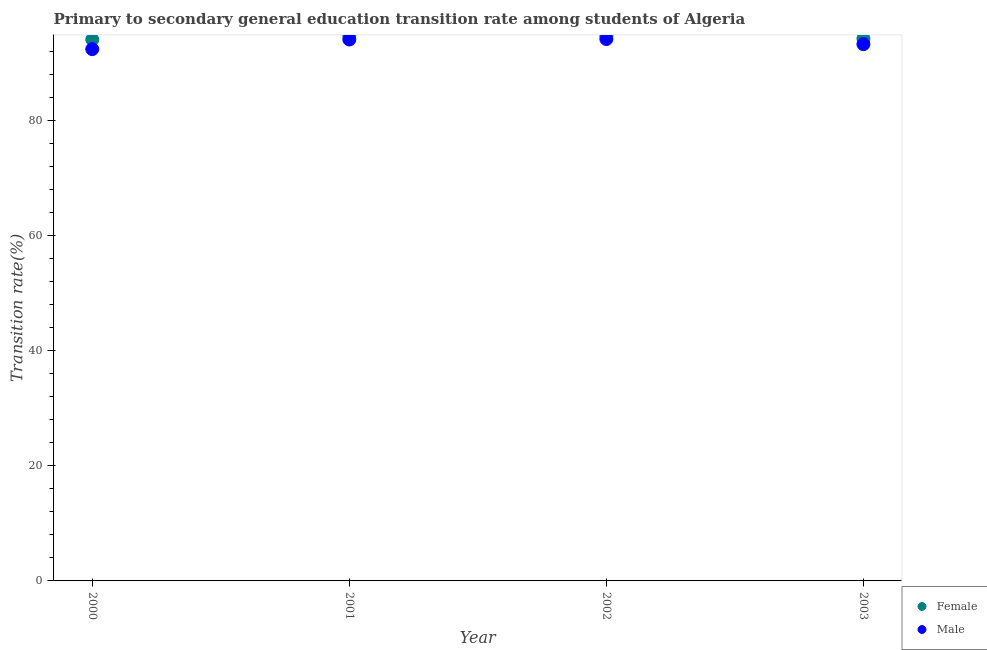Is the number of dotlines equal to the number of legend labels?
Provide a succinct answer. Yes. What is the transition rate among male students in 2002?
Your answer should be very brief. 94.22. Across all years, what is the maximum transition rate among male students?
Offer a very short reply. 94.22. Across all years, what is the minimum transition rate among female students?
Give a very brief answer. 94.12. What is the total transition rate among male students in the graph?
Offer a very short reply. 374.14. What is the difference between the transition rate among female students in 2001 and that in 2003?
Make the answer very short. 0.53. What is the difference between the transition rate among male students in 2003 and the transition rate among female students in 2002?
Provide a succinct answer. -1.41. What is the average transition rate among male students per year?
Provide a short and direct response. 93.54. In the year 2000, what is the difference between the transition rate among male students and transition rate among female students?
Give a very brief answer. -1.66. In how many years, is the transition rate among male students greater than 72 %?
Your response must be concise. 4. What is the ratio of the transition rate among female students in 2001 to that in 2002?
Give a very brief answer. 1. What is the difference between the highest and the second highest transition rate among male students?
Provide a succinct answer. 0.07. What is the difference between the highest and the lowest transition rate among male students?
Your answer should be very brief. 1.75. Is the sum of the transition rate among female students in 2001 and 2002 greater than the maximum transition rate among male students across all years?
Give a very brief answer. Yes. How many years are there in the graph?
Offer a very short reply. 4. What is the difference between two consecutive major ticks on the Y-axis?
Your answer should be very brief. 20. Are the values on the major ticks of Y-axis written in scientific E-notation?
Keep it short and to the point. No. How many legend labels are there?
Offer a very short reply. 2. What is the title of the graph?
Make the answer very short. Primary to secondary general education transition rate among students of Algeria. What is the label or title of the X-axis?
Offer a terse response. Year. What is the label or title of the Y-axis?
Your response must be concise. Transition rate(%). What is the Transition rate(%) of Female in 2000?
Make the answer very short. 94.12. What is the Transition rate(%) in Male in 2000?
Your response must be concise. 92.46. What is the Transition rate(%) of Female in 2001?
Offer a very short reply. 94.82. What is the Transition rate(%) in Male in 2001?
Ensure brevity in your answer.  94.14. What is the Transition rate(%) in Female in 2002?
Your response must be concise. 94.74. What is the Transition rate(%) of Male in 2002?
Give a very brief answer. 94.22. What is the Transition rate(%) of Female in 2003?
Offer a very short reply. 94.29. What is the Transition rate(%) in Male in 2003?
Offer a very short reply. 93.33. Across all years, what is the maximum Transition rate(%) in Female?
Offer a terse response. 94.82. Across all years, what is the maximum Transition rate(%) of Male?
Offer a terse response. 94.22. Across all years, what is the minimum Transition rate(%) in Female?
Provide a succinct answer. 94.12. Across all years, what is the minimum Transition rate(%) of Male?
Your answer should be compact. 92.46. What is the total Transition rate(%) of Female in the graph?
Offer a terse response. 377.97. What is the total Transition rate(%) of Male in the graph?
Ensure brevity in your answer.  374.14. What is the difference between the Transition rate(%) in Female in 2000 and that in 2001?
Your response must be concise. -0.7. What is the difference between the Transition rate(%) in Male in 2000 and that in 2001?
Offer a terse response. -1.68. What is the difference between the Transition rate(%) in Female in 2000 and that in 2002?
Provide a short and direct response. -0.62. What is the difference between the Transition rate(%) in Male in 2000 and that in 2002?
Your answer should be very brief. -1.75. What is the difference between the Transition rate(%) in Female in 2000 and that in 2003?
Offer a terse response. -0.17. What is the difference between the Transition rate(%) in Male in 2000 and that in 2003?
Keep it short and to the point. -0.87. What is the difference between the Transition rate(%) in Female in 2001 and that in 2002?
Provide a short and direct response. 0.09. What is the difference between the Transition rate(%) in Male in 2001 and that in 2002?
Provide a succinct answer. -0.07. What is the difference between the Transition rate(%) in Female in 2001 and that in 2003?
Offer a terse response. 0.53. What is the difference between the Transition rate(%) in Male in 2001 and that in 2003?
Your response must be concise. 0.81. What is the difference between the Transition rate(%) of Female in 2002 and that in 2003?
Ensure brevity in your answer.  0.45. What is the difference between the Transition rate(%) of Male in 2002 and that in 2003?
Your answer should be compact. 0.89. What is the difference between the Transition rate(%) of Female in 2000 and the Transition rate(%) of Male in 2001?
Keep it short and to the point. -0.02. What is the difference between the Transition rate(%) of Female in 2000 and the Transition rate(%) of Male in 2002?
Your answer should be compact. -0.09. What is the difference between the Transition rate(%) in Female in 2000 and the Transition rate(%) in Male in 2003?
Offer a very short reply. 0.79. What is the difference between the Transition rate(%) of Female in 2001 and the Transition rate(%) of Male in 2002?
Your response must be concise. 0.61. What is the difference between the Transition rate(%) of Female in 2001 and the Transition rate(%) of Male in 2003?
Your response must be concise. 1.5. What is the difference between the Transition rate(%) of Female in 2002 and the Transition rate(%) of Male in 2003?
Your answer should be compact. 1.41. What is the average Transition rate(%) in Female per year?
Provide a short and direct response. 94.49. What is the average Transition rate(%) of Male per year?
Offer a very short reply. 93.54. In the year 2000, what is the difference between the Transition rate(%) of Female and Transition rate(%) of Male?
Your response must be concise. 1.66. In the year 2001, what is the difference between the Transition rate(%) in Female and Transition rate(%) in Male?
Your answer should be compact. 0.68. In the year 2002, what is the difference between the Transition rate(%) in Female and Transition rate(%) in Male?
Provide a succinct answer. 0.52. In the year 2003, what is the difference between the Transition rate(%) of Female and Transition rate(%) of Male?
Provide a succinct answer. 0.96. What is the ratio of the Transition rate(%) of Male in 2000 to that in 2001?
Offer a very short reply. 0.98. What is the ratio of the Transition rate(%) in Male in 2000 to that in 2002?
Your answer should be compact. 0.98. What is the ratio of the Transition rate(%) in Male in 2000 to that in 2003?
Offer a very short reply. 0.99. What is the ratio of the Transition rate(%) in Female in 2001 to that in 2002?
Provide a succinct answer. 1. What is the ratio of the Transition rate(%) of Female in 2001 to that in 2003?
Ensure brevity in your answer.  1.01. What is the ratio of the Transition rate(%) in Male in 2001 to that in 2003?
Keep it short and to the point. 1.01. What is the ratio of the Transition rate(%) of Male in 2002 to that in 2003?
Your answer should be very brief. 1.01. What is the difference between the highest and the second highest Transition rate(%) of Female?
Offer a terse response. 0.09. What is the difference between the highest and the second highest Transition rate(%) in Male?
Ensure brevity in your answer.  0.07. What is the difference between the highest and the lowest Transition rate(%) of Female?
Your answer should be very brief. 0.7. What is the difference between the highest and the lowest Transition rate(%) of Male?
Give a very brief answer. 1.75. 